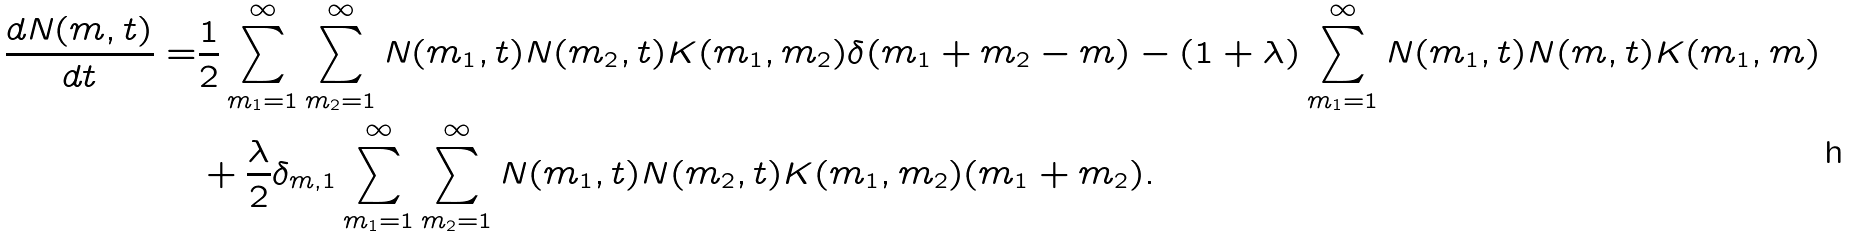<formula> <loc_0><loc_0><loc_500><loc_500>\frac { d N ( m , t ) } { d t } = & \frac { 1 } { 2 } \sum _ { m _ { 1 } = 1 } ^ { \infty } \sum _ { m _ { 2 } = 1 } ^ { \infty } N ( m _ { 1 } , t ) N ( m _ { 2 } , t ) K ( m _ { 1 } , m _ { 2 } ) \delta ( m _ { 1 } + m _ { 2 } - m ) - ( 1 + \lambda ) \sum _ { m _ { 1 } = 1 } ^ { \infty } N ( m _ { 1 } , t ) N ( m , t ) K ( m _ { 1 } , m ) \\ & + \frac { \lambda } { 2 } \delta _ { m , 1 } \sum _ { m _ { 1 } = 1 } ^ { \infty } \sum _ { m _ { 2 } = 1 } ^ { \infty } N ( m _ { 1 } , t ) N ( m _ { 2 } , t ) K ( m _ { 1 } , m _ { 2 } ) ( m _ { 1 } + m _ { 2 } ) .</formula> 